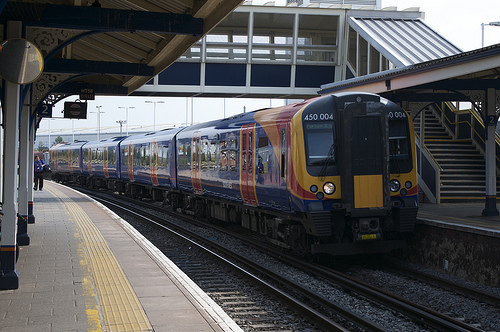Please provide the bounding box coordinate of the region this sentence describes: a man on the sidewalk. In the image, a man is located on the sidewalk, clearly visible within the coordinates [0.06, 0.47, 0.11, 0.56]. This specific area captures his presence as he likely waits or walks near the train station. 